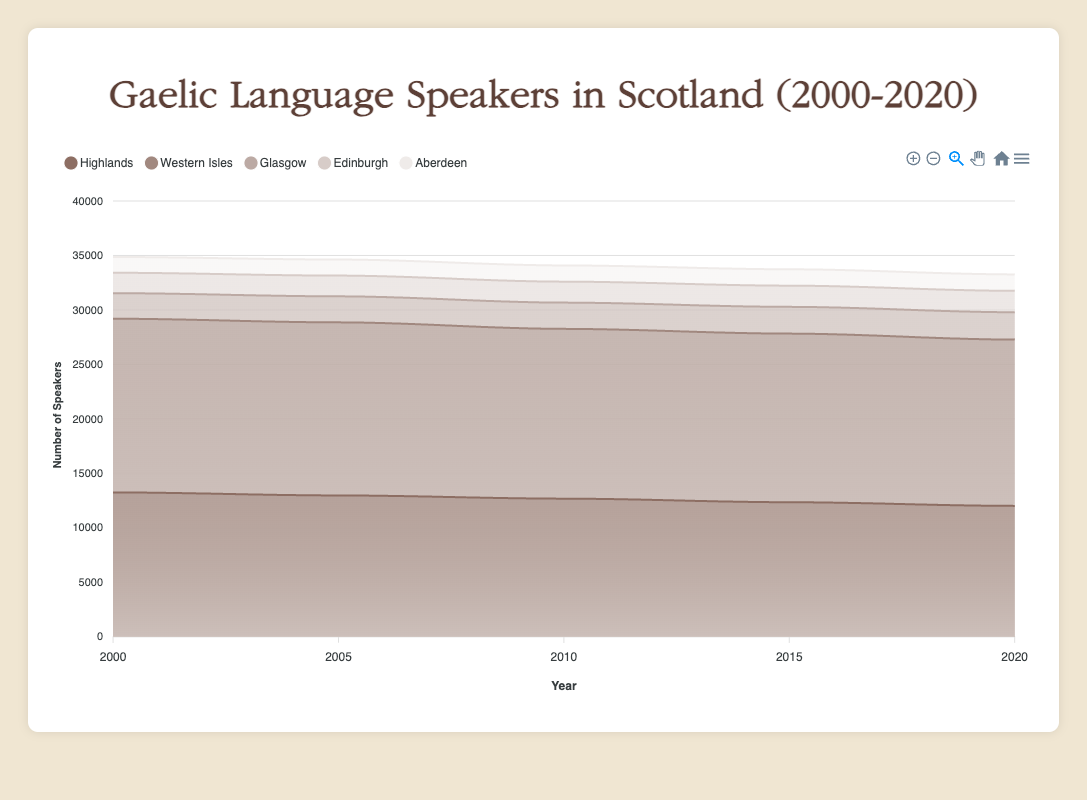What region has the highest number of Gaelic language speakers in 2000? The region with the highest number of speakers can be found by looking at the topmost colored area in 2000 on the area chart.
Answer: Western Isles How does the number of Gaelic speakers in Edinburgh change from 2000 to 2020? The number of Gaelic speakers in Edinburgh in 2000 is at 1874 and in 2020 it's at 1964, indicating an increase over this period.
Answer: It increases Which region shows the most consistent decline in the number of Gaelic speakers from 2000 to 2020? To find the region with the most consistent decline, observe which region’s colored area show a downward pattern consistently between 2000 and 2020.
Answer: Highlands What is the total number of Gaelic speakers in the Western Isles and Glasgow combined in 2010? Sum of the number of speakers in the Western Isles (15587) and Glasgow (2410) in 2010.
Answer: 17997 Which year shows the highest number of Gaelic speakers in Glasgow? Reviewing the data points for Glasgow across various years on the chart, we see the peak occurs in 2020.
Answer: 2020 Which regions have more than 5000 Gaelic speakers throughout the entire period from 2000 to 2020? Check each region's lowermost value in the area chart and ensure it remains above 5000 from 2000 to 2020.
Answer: Highlands, Western Isles Does the number of Gaelic speakers in Western Isles ever show an increase in any period? Evaluate if the height of the colored area for the Western Isles in any given period rises from one point to another. All bars slightly decrease in every period.
Answer: No In which year does Edinburgh have the smallest number of Gaelic speakers? Observing the colored area related to Edinburgh for each year, the smallest area is in 2000 with 1874 speakers.
Answer: 2000 How many years show over 15000 Gaelic speakers in the Western Isles? Observe the area chart color segmenting for the Western Isles; count the years above 15000 speakers by examining the y-axis.
Answer: 5 Years By how much does the number of Gaelic speakers in Aberdeen change from 2005 to 2020? Subtract the number of Gaelic speakers in Aberdeen in 2005 (1473) from that in 2020 (1510).
Answer: Increases by 37 